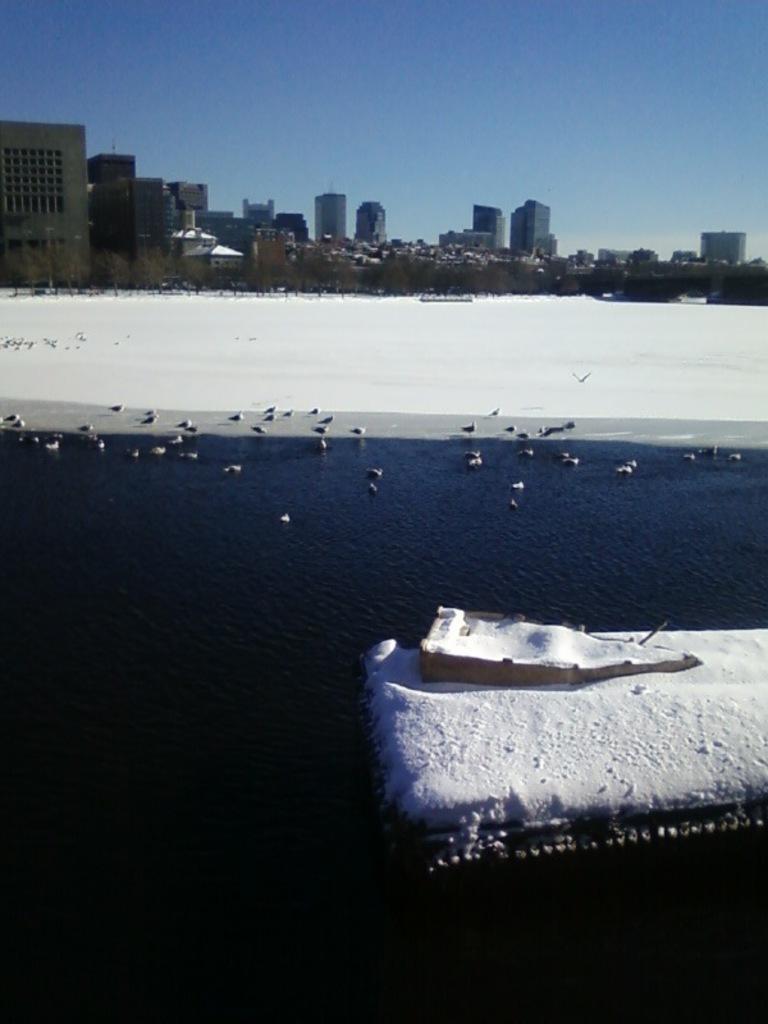Can you describe this image briefly? In this image I can see few buildings, trees, snow, few birds and the water. In front I can see an object and the snow on it. The sky is in blue and white color. 